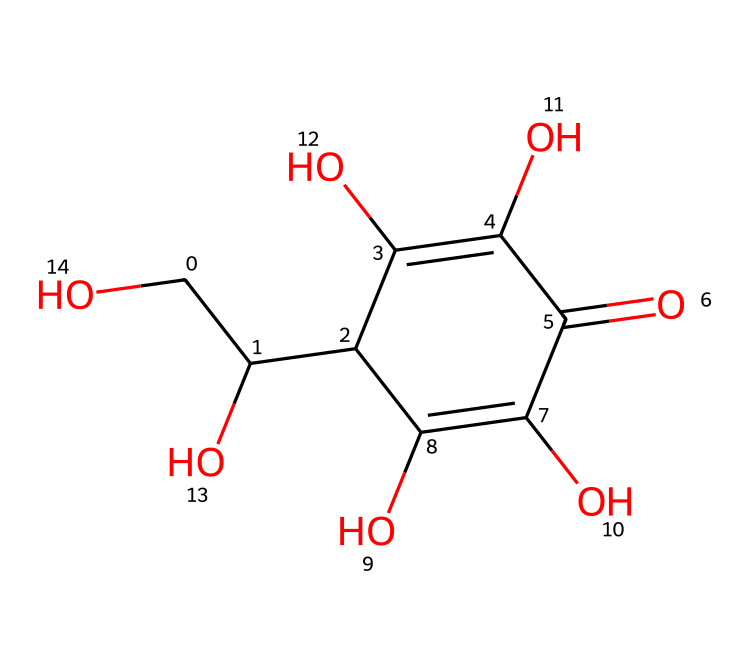What is the main structural feature that defines this vitamin as a sugar acid? The chemical structure shows multiple hydroxyl (-OH) groups and a carboxylic acid group (C(=O)O) which indicate that it is a sugar acid.
Answer: sugar acid How many hydroxyl groups are present in the structure of vitamin C? By analyzing the structure, we can count four -OH groups present at different carbon atoms in the molecule.
Answer: four What is the number of carbon atoms in vitamin C? The skeleton of the structure shows a total of six carbon atoms connected in the molecular arrangement.
Answer: six Which natural source is primarily known for containing vitamin C? Historically, citrus fruits like oranges and lemons are well-known for their high vitamin C content.
Answer: citrus fruits What is the role of the double bond in the chemical structure of vitamin C? The double bond in the structure contributes to the overall reactivity and property of the compound, affecting its stability and interaction with other substances.
Answer: reactivity How many oxygen atoms are there in the chemical structure of vitamin C? Counting the oxygen atoms in the structure reveals that there are a total of six oxygen atoms present.
Answer: six 